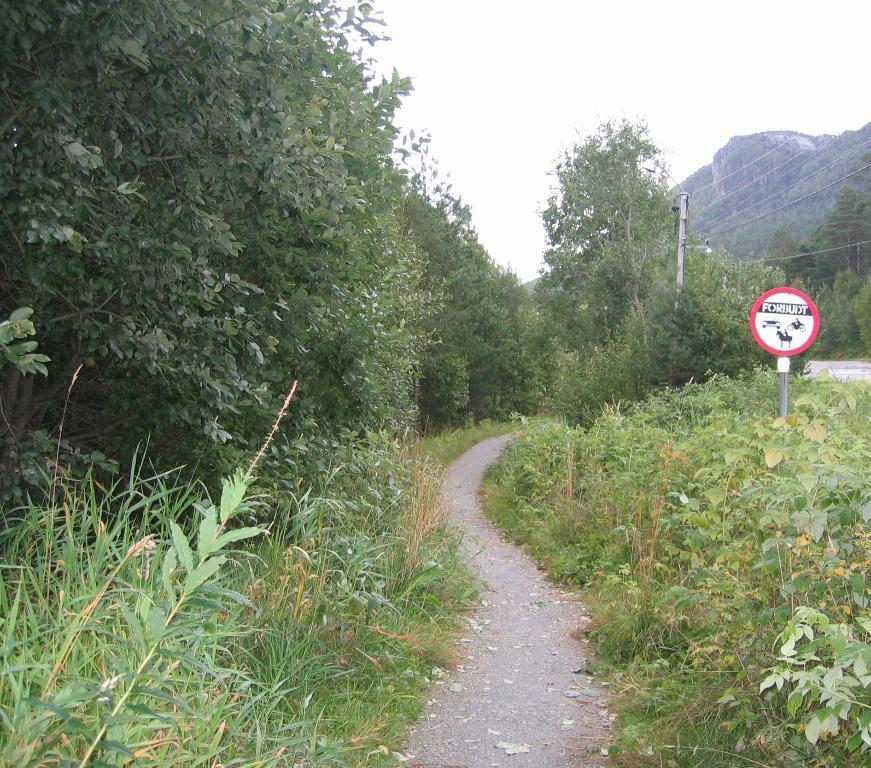Could you give a brief overview of what you see in this image? In this image there is a signboard, poles, plants, road, trees, hill and sky. 